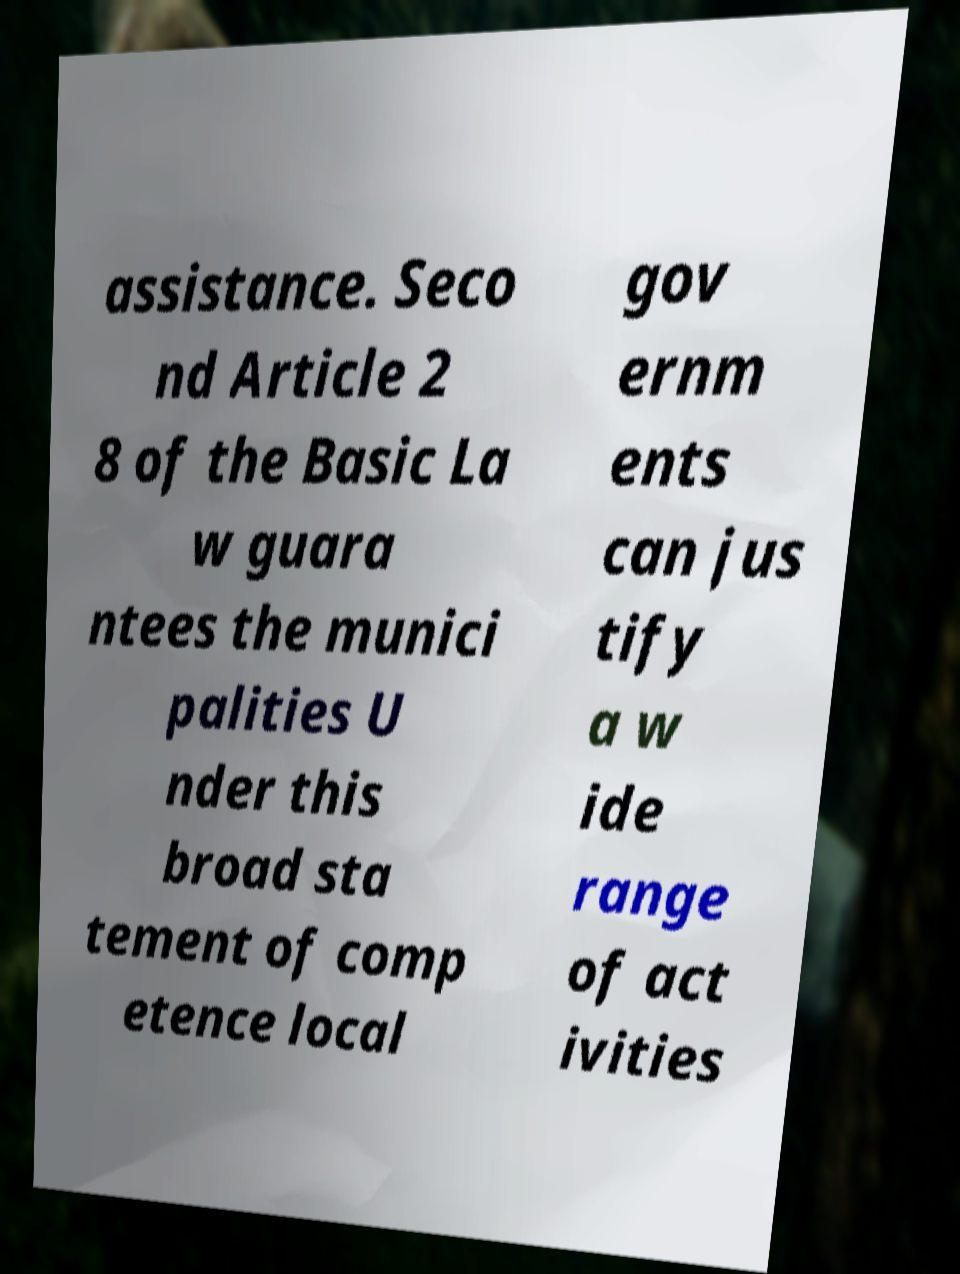There's text embedded in this image that I need extracted. Can you transcribe it verbatim? assistance. Seco nd Article 2 8 of the Basic La w guara ntees the munici palities U nder this broad sta tement of comp etence local gov ernm ents can jus tify a w ide range of act ivities 